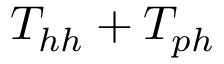Convert formula to latex. <formula><loc_0><loc_0><loc_500><loc_500>T _ { h h } + T _ { p h }</formula> 